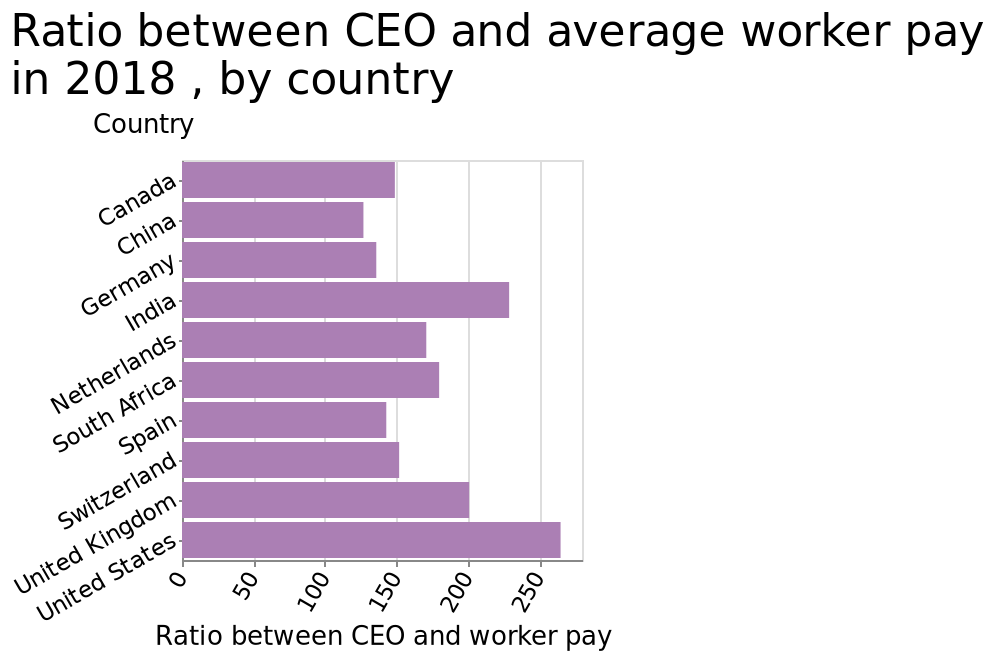<image>
What does the y-axis represent in the bar plot? The y-axis represents the countries in the bar plot. please enumerates aspects of the construction of the chart Here a bar plot is labeled Ratio between CEO and average worker pay in 2018 , by country. The y-axis shows Country while the x-axis shows Ratio between CEO and worker pay. What does a higher ratio between CEO and worker pay indicate in the bar plot? A higher ratio between CEO and worker pay indicates a larger income disparity between CEOs and average workers in a particular country. What does the x-axis represent in the bar plot? The x-axis represents the ratio between CEO and worker pay. What is the approximate ratio between CEO and worker pay in the United States? The approximate ratio between CEO and worker pay in the United States is around 260. 